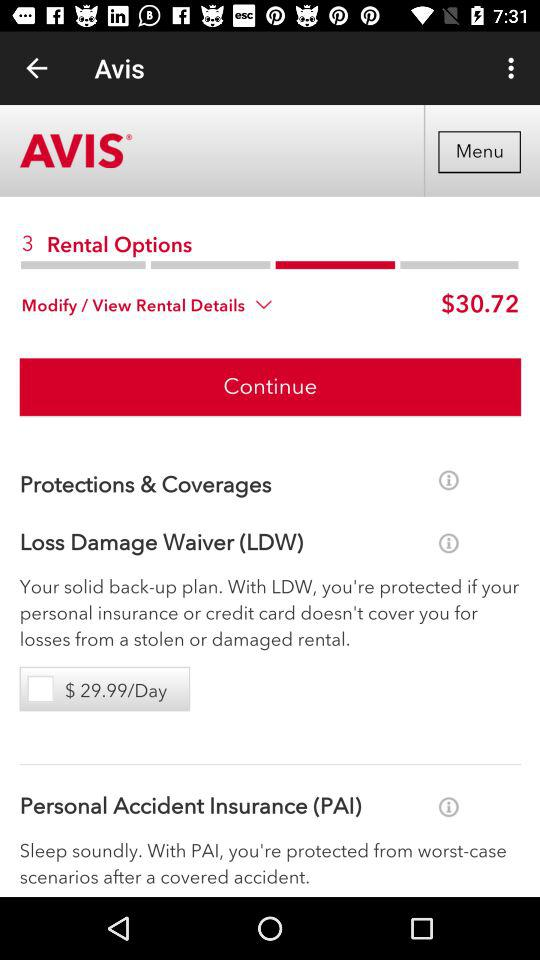How many rental options are there? There are 3 rental options. 